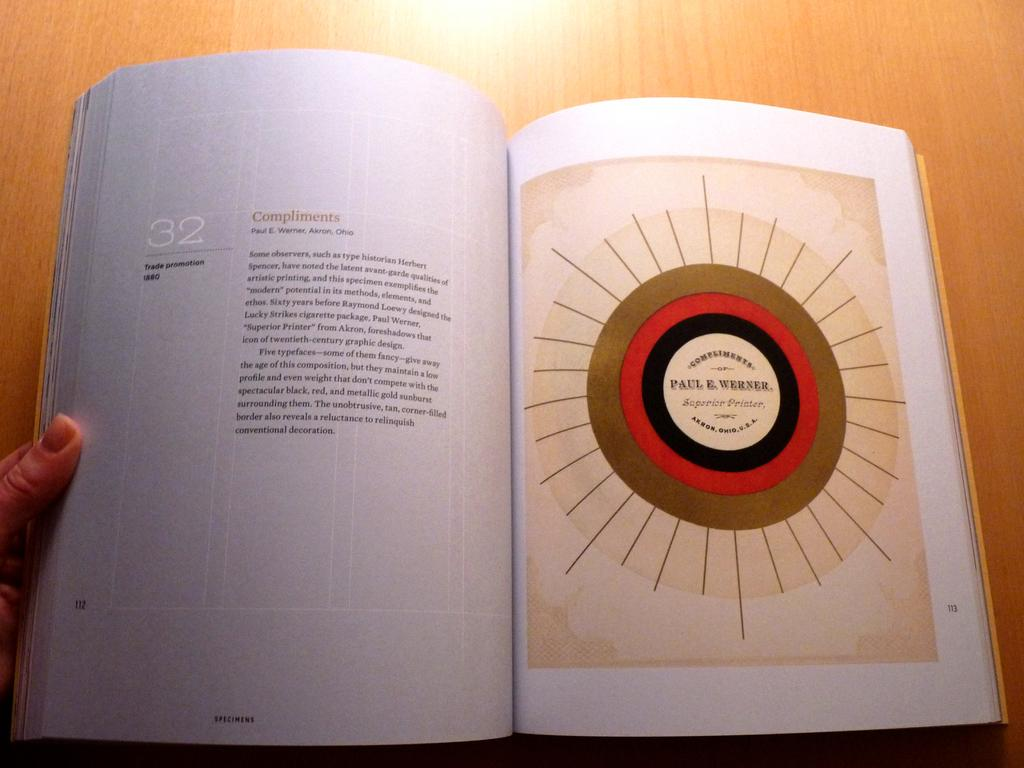<image>
Provide a brief description of the given image. Open book with a page showing a circle and the name Paul E. Werner in it. 